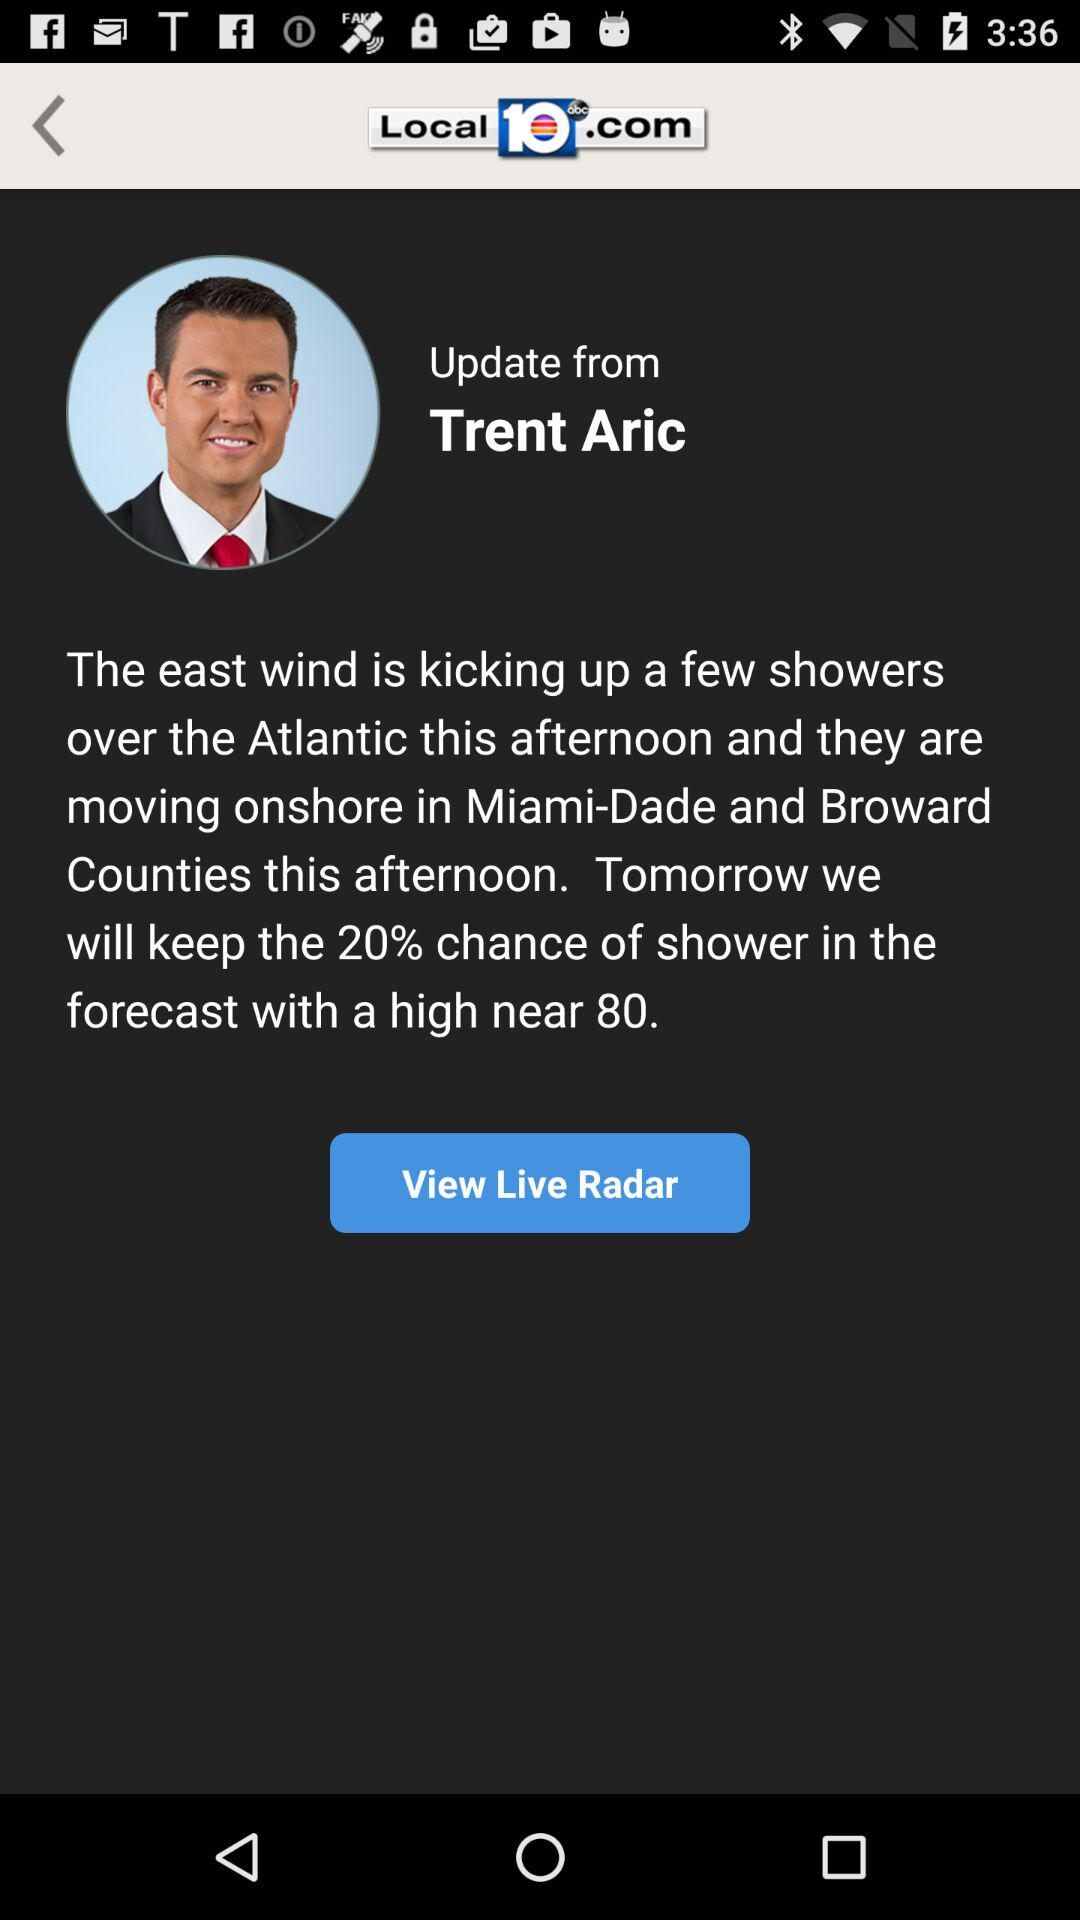What is the application name? The application name is "Local 10 - WPLG Miami". 